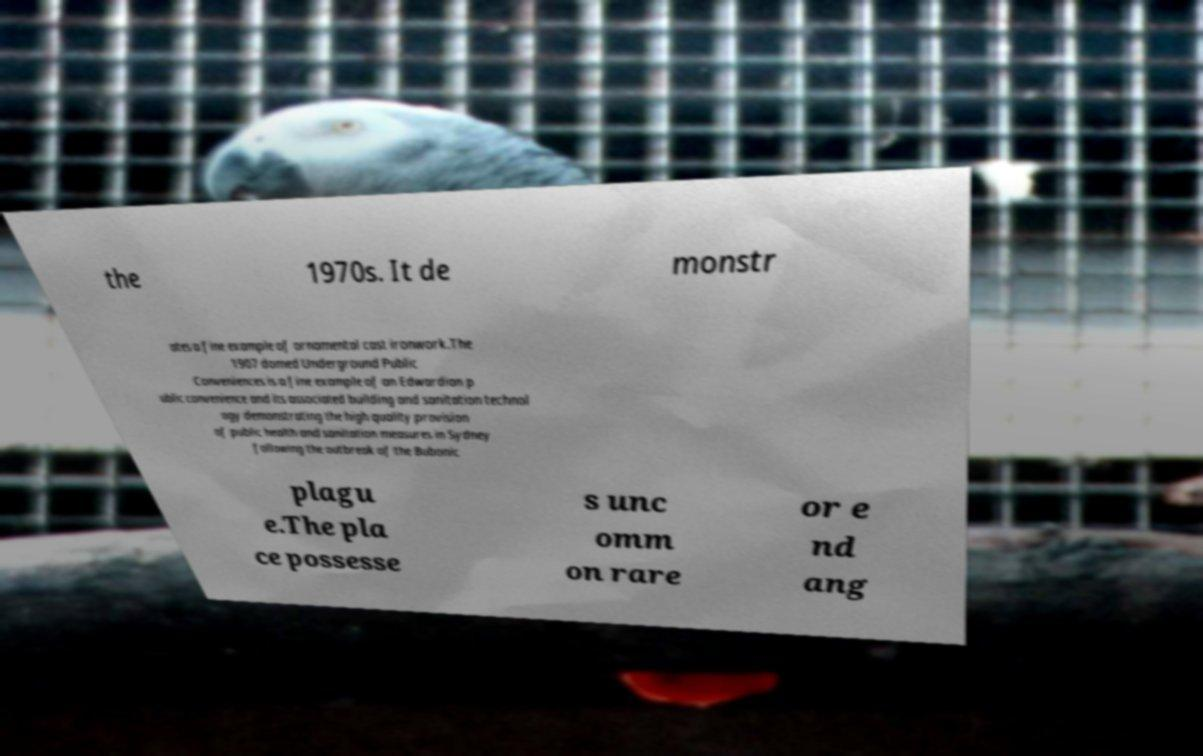Could you assist in decoding the text presented in this image and type it out clearly? the 1970s. It de monstr ates a fine example of ornamental cast ironwork.The 1907 domed Underground Public Conveniences is a fine example of an Edwardian p ublic convenience and its associated building and sanitation technol ogy demonstrating the high quality provision of public health and sanitation measures in Sydney following the outbreak of the Bubonic plagu e.The pla ce possesse s unc omm on rare or e nd ang 